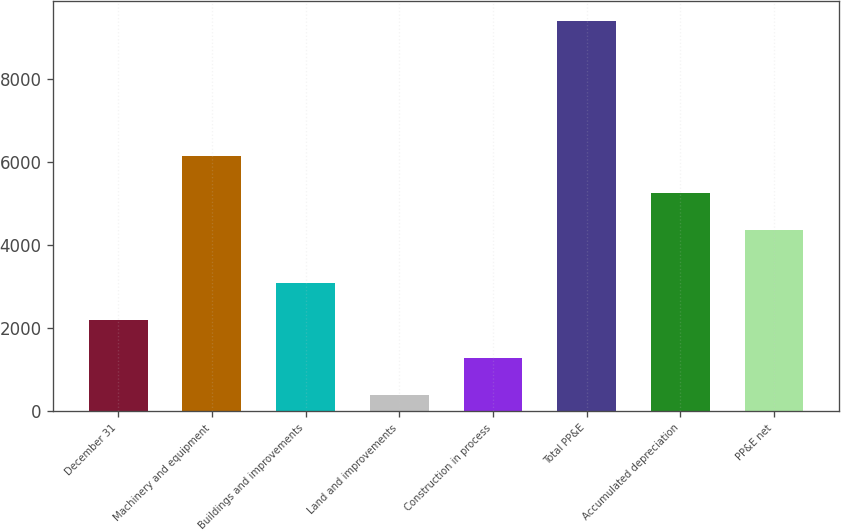Convert chart to OTSL. <chart><loc_0><loc_0><loc_500><loc_500><bar_chart><fcel>December 31<fcel>Machinery and equipment<fcel>Buildings and improvements<fcel>Land and improvements<fcel>Construction in process<fcel>Total PP&E<fcel>Accumulated depreciation<fcel>PP&E net<nl><fcel>2189.4<fcel>6151.4<fcel>3091.1<fcel>386<fcel>1287.7<fcel>9403<fcel>5249.7<fcel>4348<nl></chart> 